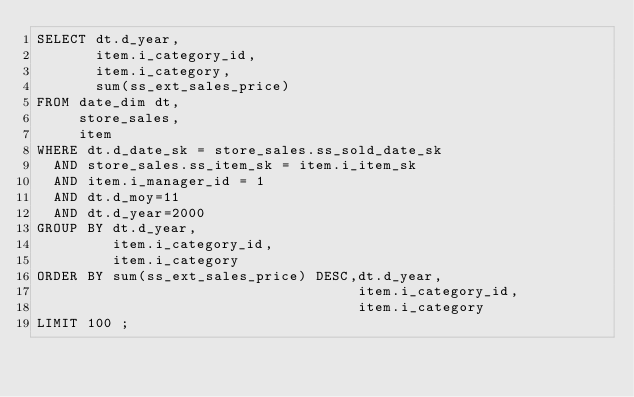<code> <loc_0><loc_0><loc_500><loc_500><_SQL_>SELECT dt.d_year,
       item.i_category_id,
       item.i_category,
       sum(ss_ext_sales_price)
FROM date_dim dt,
     store_sales,
     item
WHERE dt.d_date_sk = store_sales.ss_sold_date_sk
  AND store_sales.ss_item_sk = item.i_item_sk
  AND item.i_manager_id = 1
  AND dt.d_moy=11
  AND dt.d_year=2000
GROUP BY dt.d_year,
         item.i_category_id,
         item.i_category
ORDER BY sum(ss_ext_sales_price) DESC,dt.d_year,
                                      item.i_category_id,
                                      item.i_category
LIMIT 100 ;

</code> 